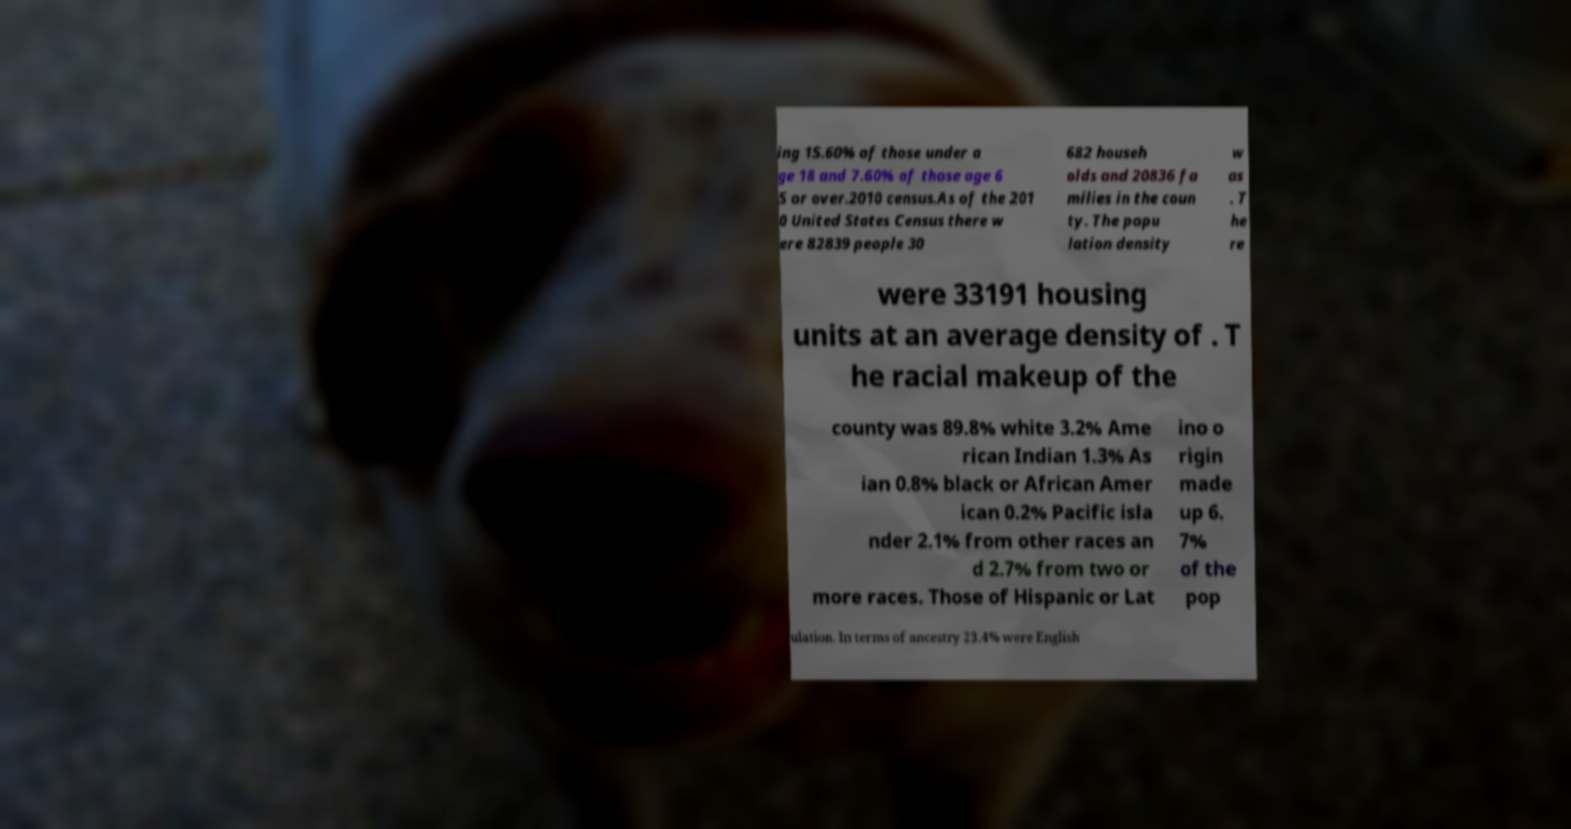Please identify and transcribe the text found in this image. ing 15.60% of those under a ge 18 and 7.60% of those age 6 5 or over.2010 census.As of the 201 0 United States Census there w ere 82839 people 30 682 househ olds and 20836 fa milies in the coun ty. The popu lation density w as . T he re were 33191 housing units at an average density of . T he racial makeup of the county was 89.8% white 3.2% Ame rican Indian 1.3% As ian 0.8% black or African Amer ican 0.2% Pacific isla nder 2.1% from other races an d 2.7% from two or more races. Those of Hispanic or Lat ino o rigin made up 6. 7% of the pop ulation. In terms of ancestry 23.4% were English 